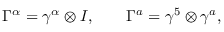<formula> <loc_0><loc_0><loc_500><loc_500>\Gamma ^ { \alpha } = \gamma ^ { \alpha } \otimes I , \quad G a m m a ^ { a } = \gamma ^ { 5 } \otimes \gamma ^ { a } ,</formula> 